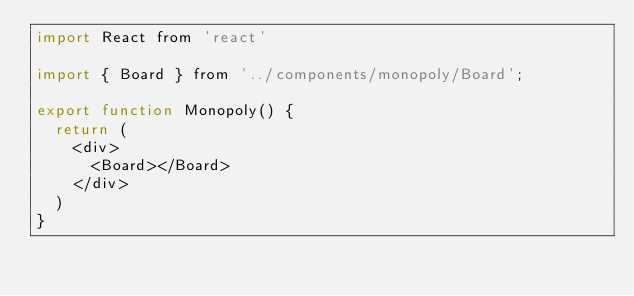<code> <loc_0><loc_0><loc_500><loc_500><_JavaScript_>import React from 'react'

import { Board } from '../components/monopoly/Board';

export function Monopoly() {
  return (
    <div>
      <Board></Board>
    </div>
  )
}
</code> 